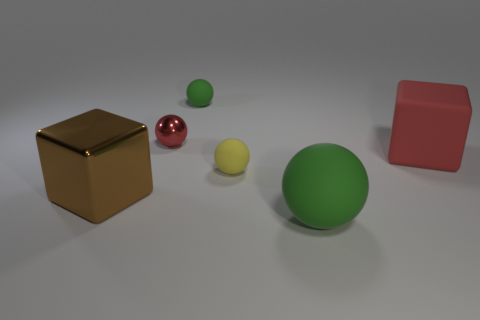Add 3 big brown blocks. How many objects exist? 9 Subtract all spheres. How many objects are left? 2 Subtract 1 yellow spheres. How many objects are left? 5 Subtract all small purple metallic cylinders. Subtract all small green matte spheres. How many objects are left? 5 Add 3 small red things. How many small red things are left? 4 Add 3 big green blocks. How many big green blocks exist? 3 